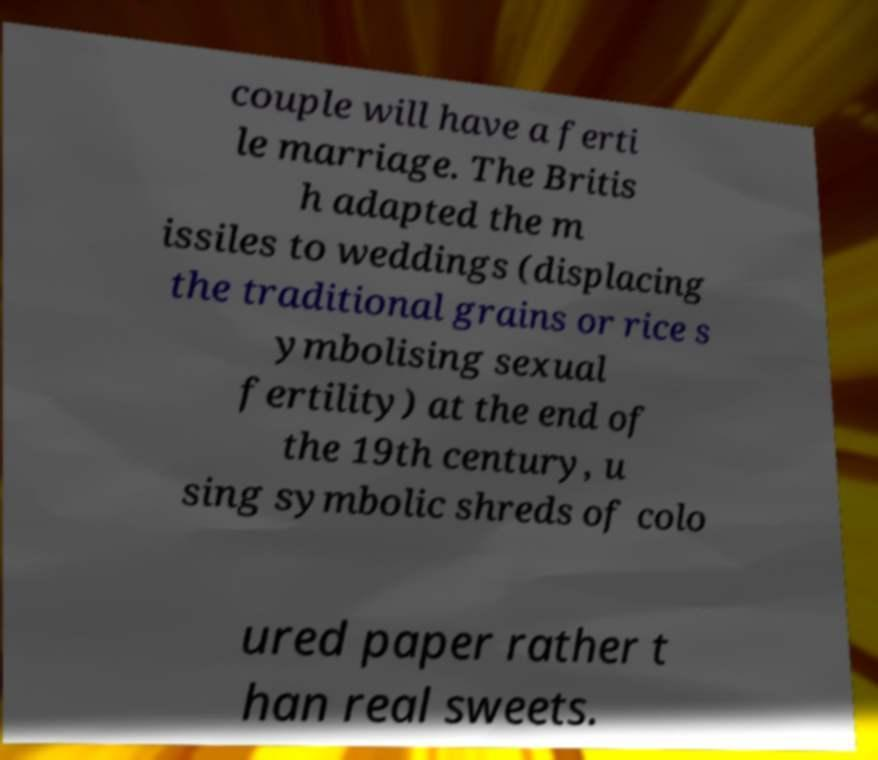Please identify and transcribe the text found in this image. couple will have a ferti le marriage. The Britis h adapted the m issiles to weddings (displacing the traditional grains or rice s ymbolising sexual fertility) at the end of the 19th century, u sing symbolic shreds of colo ured paper rather t han real sweets. 